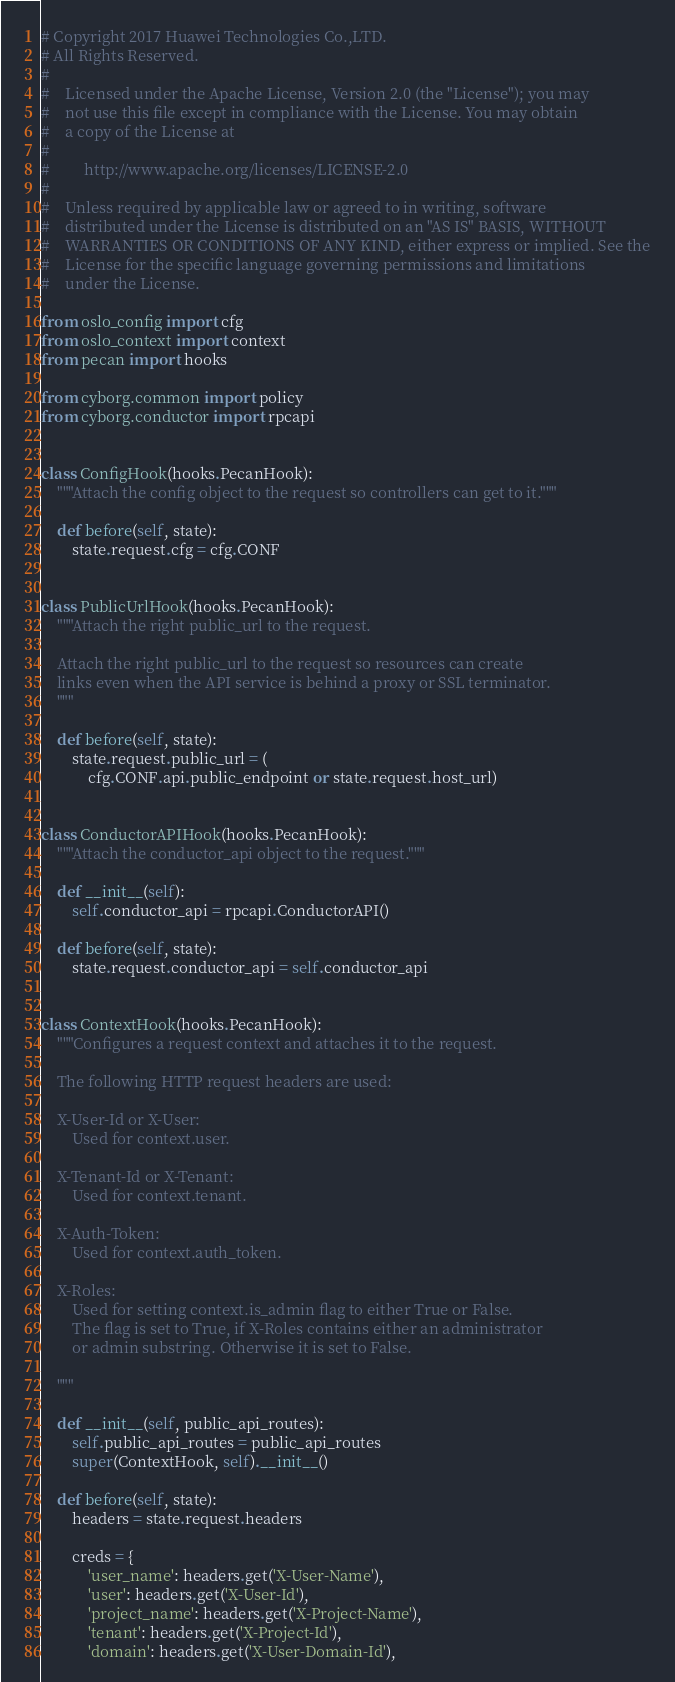<code> <loc_0><loc_0><loc_500><loc_500><_Python_># Copyright 2017 Huawei Technologies Co.,LTD.
# All Rights Reserved.
#
#    Licensed under the Apache License, Version 2.0 (the "License"); you may
#    not use this file except in compliance with the License. You may obtain
#    a copy of the License at
#
#         http://www.apache.org/licenses/LICENSE-2.0
#
#    Unless required by applicable law or agreed to in writing, software
#    distributed under the License is distributed on an "AS IS" BASIS, WITHOUT
#    WARRANTIES OR CONDITIONS OF ANY KIND, either express or implied. See the
#    License for the specific language governing permissions and limitations
#    under the License.

from oslo_config import cfg
from oslo_context import context
from pecan import hooks

from cyborg.common import policy
from cyborg.conductor import rpcapi


class ConfigHook(hooks.PecanHook):
    """Attach the config object to the request so controllers can get to it."""

    def before(self, state):
        state.request.cfg = cfg.CONF


class PublicUrlHook(hooks.PecanHook):
    """Attach the right public_url to the request.

    Attach the right public_url to the request so resources can create
    links even when the API service is behind a proxy or SSL terminator.
    """

    def before(self, state):
        state.request.public_url = (
            cfg.CONF.api.public_endpoint or state.request.host_url)


class ConductorAPIHook(hooks.PecanHook):
    """Attach the conductor_api object to the request."""

    def __init__(self):
        self.conductor_api = rpcapi.ConductorAPI()

    def before(self, state):
        state.request.conductor_api = self.conductor_api


class ContextHook(hooks.PecanHook):
    """Configures a request context and attaches it to the request.

    The following HTTP request headers are used:

    X-User-Id or X-User:
        Used for context.user.

    X-Tenant-Id or X-Tenant:
        Used for context.tenant.

    X-Auth-Token:
        Used for context.auth_token.

    X-Roles:
        Used for setting context.is_admin flag to either True or False.
        The flag is set to True, if X-Roles contains either an administrator
        or admin substring. Otherwise it is set to False.

    """

    def __init__(self, public_api_routes):
        self.public_api_routes = public_api_routes
        super(ContextHook, self).__init__()

    def before(self, state):
        headers = state.request.headers

        creds = {
            'user_name': headers.get('X-User-Name'),
            'user': headers.get('X-User-Id'),
            'project_name': headers.get('X-Project-Name'),
            'tenant': headers.get('X-Project-Id'),
            'domain': headers.get('X-User-Domain-Id'),</code> 